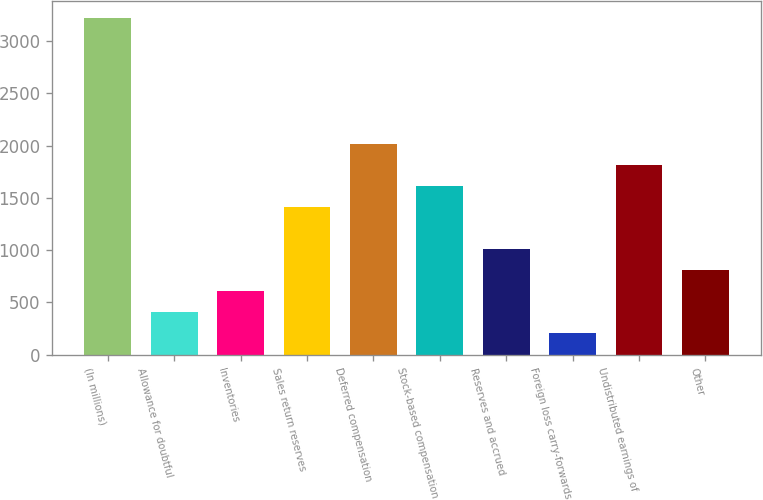Convert chart. <chart><loc_0><loc_0><loc_500><loc_500><bar_chart><fcel>(In millions)<fcel>Allowance for doubtful<fcel>Inventories<fcel>Sales return reserves<fcel>Deferred compensation<fcel>Stock-based compensation<fcel>Reserves and accrued<fcel>Foreign loss carry-forwards<fcel>Undistributed earnings of<fcel>Other<nl><fcel>3217.8<fcel>406.6<fcel>607.4<fcel>1410.6<fcel>2013<fcel>1611.4<fcel>1009<fcel>205.8<fcel>1812.2<fcel>808.2<nl></chart> 